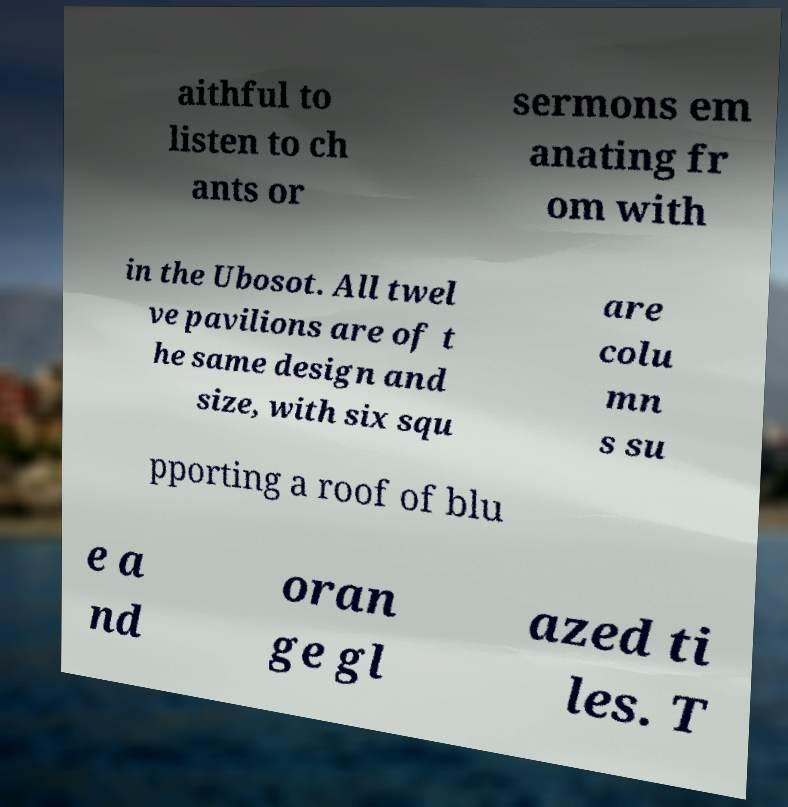What messages or text are displayed in this image? I need them in a readable, typed format. aithful to listen to ch ants or sermons em anating fr om with in the Ubosot. All twel ve pavilions are of t he same design and size, with six squ are colu mn s su pporting a roof of blu e a nd oran ge gl azed ti les. T 